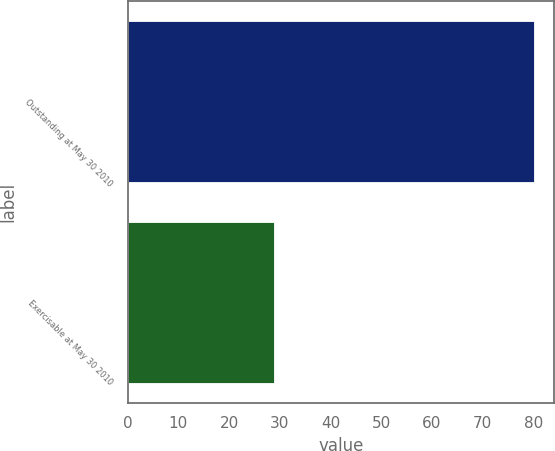Convert chart. <chart><loc_0><loc_0><loc_500><loc_500><bar_chart><fcel>Outstanding at May 30 2010<fcel>Exercisable at May 30 2010<nl><fcel>80.1<fcel>28.8<nl></chart> 